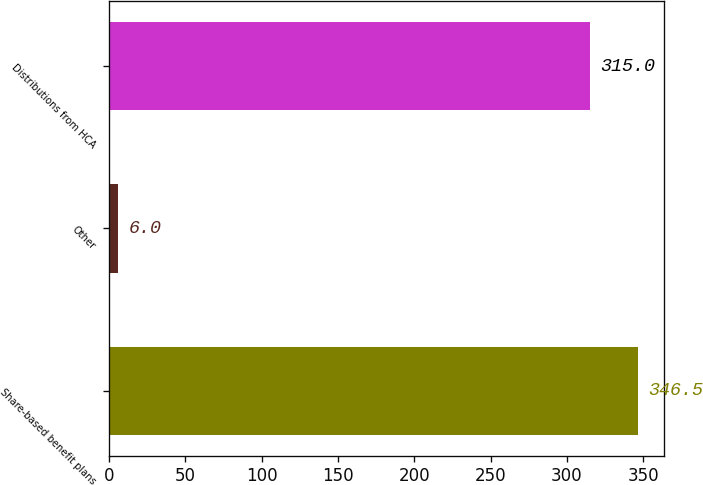Convert chart. <chart><loc_0><loc_0><loc_500><loc_500><bar_chart><fcel>Share-based benefit plans<fcel>Other<fcel>Distributions from HCA<nl><fcel>346.5<fcel>6<fcel>315<nl></chart> 